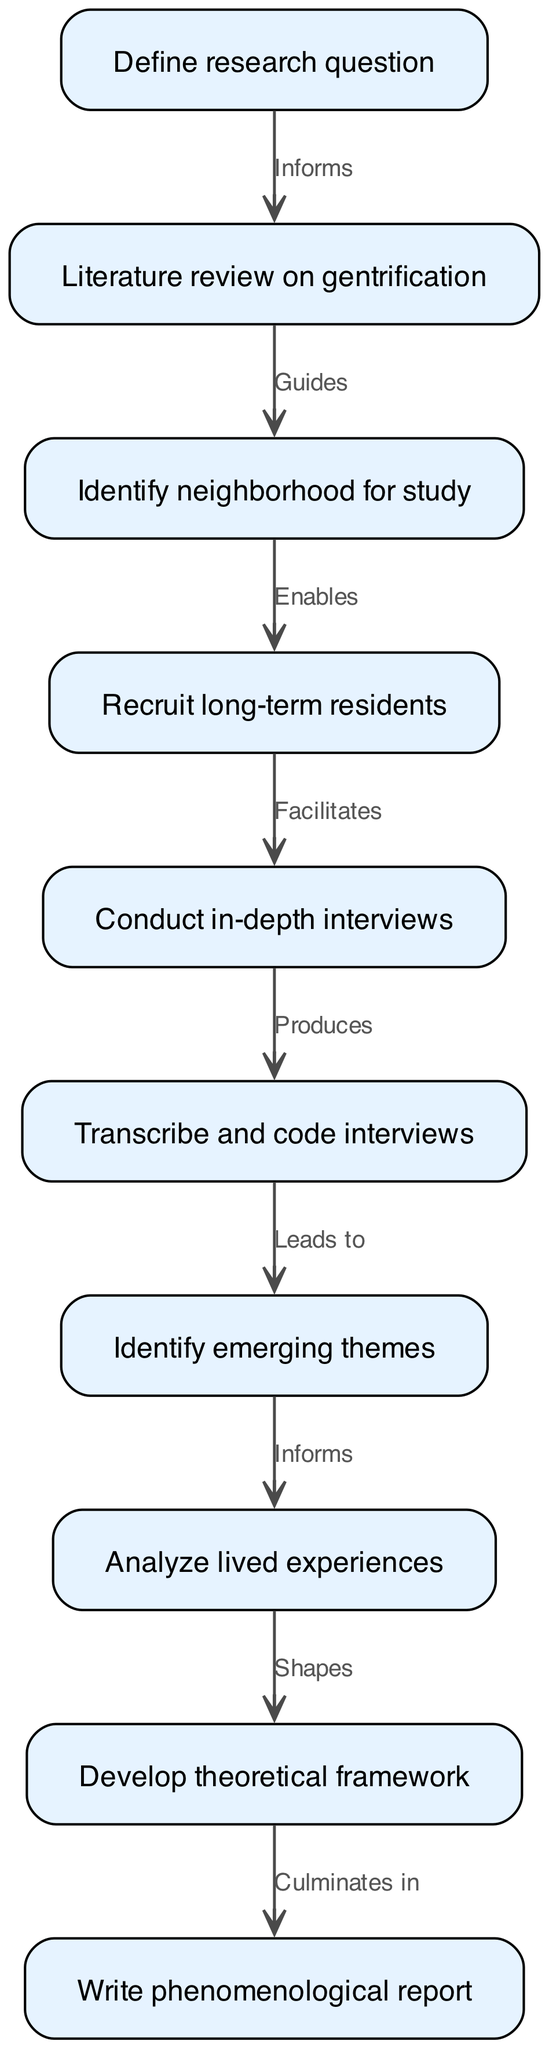What is the first stage of the study? The first stage of the study is to "Define research question," which is explicitly stated as the starting node in the flowchart.
Answer: Define research question How many nodes are present in the diagram? The diagram lists a total of ten nodes, each representing a distinct stage in the phenomenological study process.
Answer: Ten What relationship exists between "Conduct in-depth interviews" and "Transcribe and code interviews"? The relationship is that "Conduct in-depth interviews" produces the data necessary for "Transcribe and code interviews," as indicated by the edge connecting the two nodes.
Answer: Produces Which node leads to the analysis of lived experiences? The node that leads to the analysis of lived experiences is "Identify emerging themes," which informs the subsequent analysis regarding individuals' experiences.
Answer: Identify emerging themes Which stage culminates in the writing of the phenomenological report? The stage that culminates in the writing of the phenomenological report is "Develop theoretical framework," which is shown to lead directly to the report writing stage.
Answer: Develop theoretical framework How does the literature review on gentrification inform the identification of a neighborhood for study? The literature review provides the necessary background and understanding of gentrification that guides the researcher in selecting a neighborhood that exhibits relevant characteristics for the study.
Answer: Guides Explain the flow from "Recruit long-term residents" to "Conduct in-depth interviews". The process starts by recruiting long-term residents, which directly facilitates the subsequent stage of conducting in-depth interviews with these individuals to gather firsthand accounts of their experiences.
Answer: Facilitates Which stage is identified as shaping the theoretical framework? The analysis of lived experiences is identified as shaping the theoretical framework, as per the diagram's edge from the analysis to the framework development.
Answer: Analyze lived experiences What does the edge between "Transcribe and code interviews" and "Identify emerging themes" signify? This edge signifies that transcribing and coding the interviews leads directly to the identification of emerging themes, which are crucial for further analysis.
Answer: Leads to 